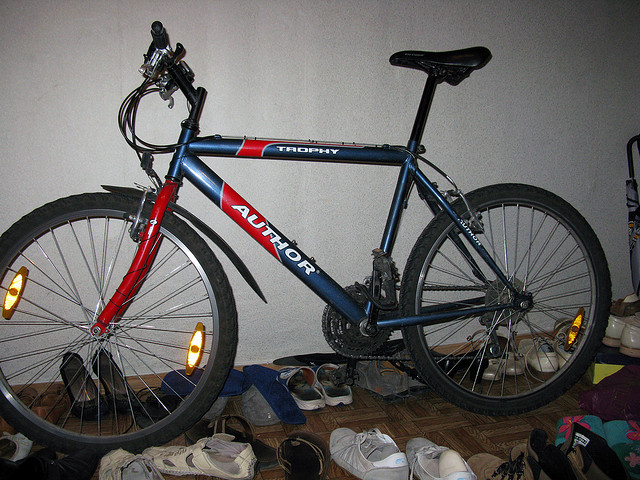<image>Name a sponsor for this rider? I am not sure about the sponsor for this rider. It could be 'author'. Name a sponsor for this rider? The sponsor for the rider is author. 